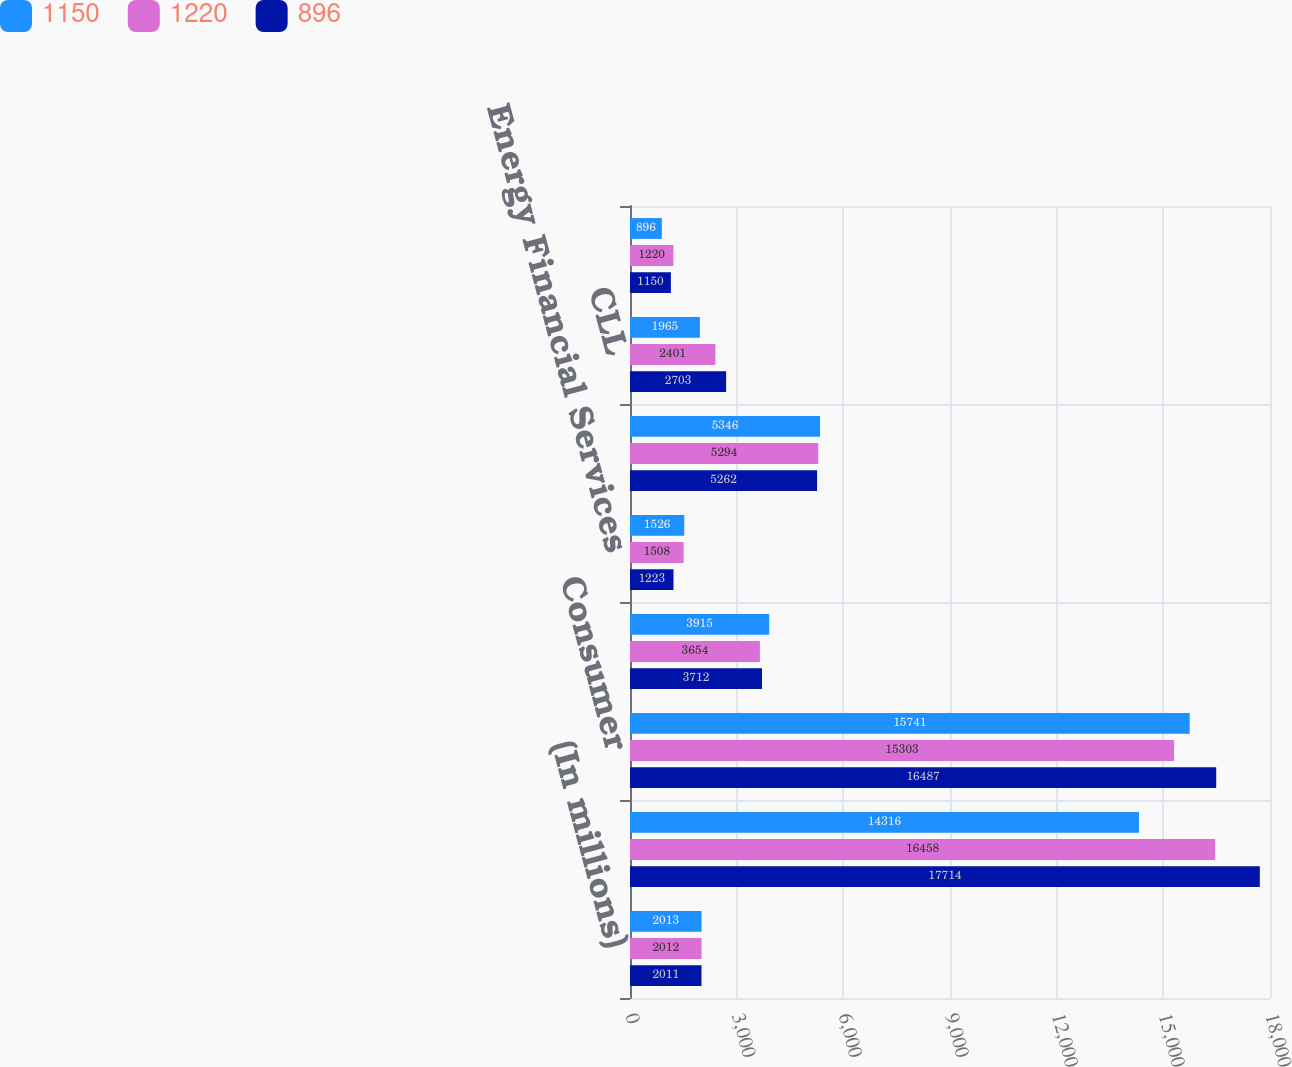Convert chart to OTSL. <chart><loc_0><loc_0><loc_500><loc_500><stacked_bar_chart><ecel><fcel>(In millions)<fcel>Commercial Lending and Leasing<fcel>Consumer<fcel>Real Estate<fcel>Energy Financial Services<fcel>GE Capital Aviation Services<fcel>CLL<fcel>GECAS<nl><fcel>1150<fcel>2013<fcel>14316<fcel>15741<fcel>3915<fcel>1526<fcel>5346<fcel>1965<fcel>896<nl><fcel>1220<fcel>2012<fcel>16458<fcel>15303<fcel>3654<fcel>1508<fcel>5294<fcel>2401<fcel>1220<nl><fcel>896<fcel>2011<fcel>17714<fcel>16487<fcel>3712<fcel>1223<fcel>5262<fcel>2703<fcel>1150<nl></chart> 